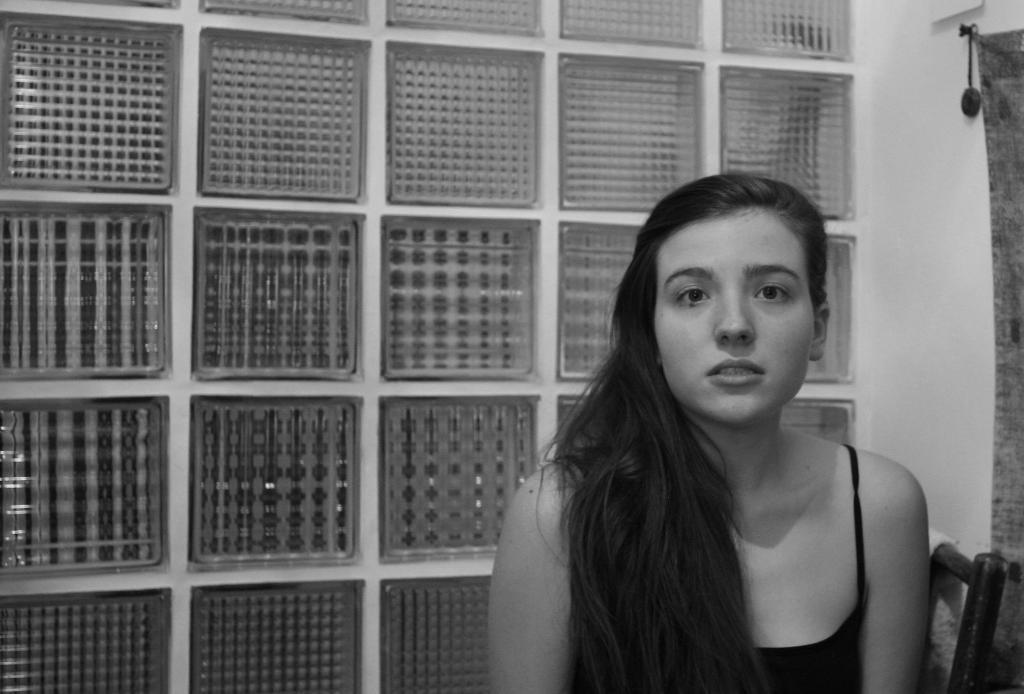Could you give a brief overview of what you see in this image? In this image we can see a black and white picture of a person sitting on the chair and there is a wall with few objects in the background. 